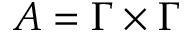<formula> <loc_0><loc_0><loc_500><loc_500>A = \Gamma \times \Gamma</formula> 